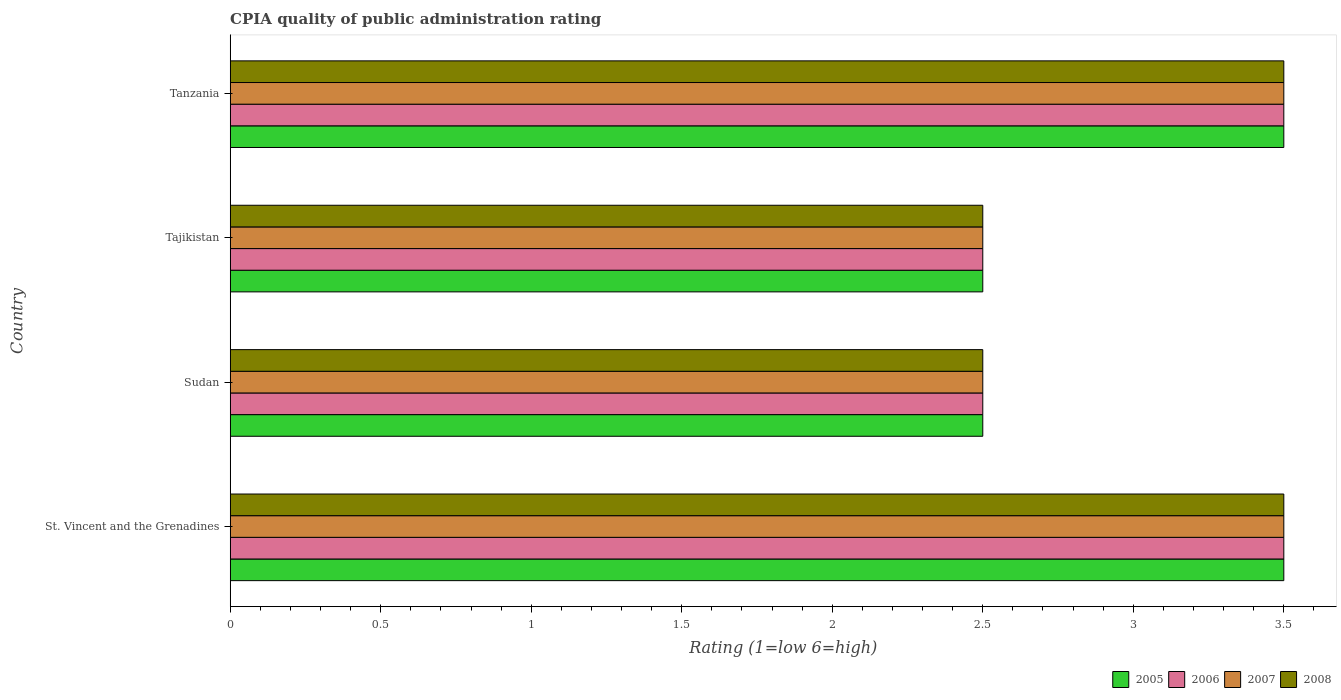How many different coloured bars are there?
Provide a short and direct response. 4. Are the number of bars on each tick of the Y-axis equal?
Give a very brief answer. Yes. What is the label of the 3rd group of bars from the top?
Offer a terse response. Sudan. In how many cases, is the number of bars for a given country not equal to the number of legend labels?
Keep it short and to the point. 0. What is the CPIA rating in 2008 in St. Vincent and the Grenadines?
Your answer should be very brief. 3.5. Across all countries, what is the minimum CPIA rating in 2007?
Provide a succinct answer. 2.5. In which country was the CPIA rating in 2008 maximum?
Ensure brevity in your answer.  St. Vincent and the Grenadines. In which country was the CPIA rating in 2007 minimum?
Keep it short and to the point. Sudan. What is the average CPIA rating in 2006 per country?
Your answer should be compact. 3. What is the difference between the CPIA rating in 2007 and CPIA rating in 2006 in St. Vincent and the Grenadines?
Your answer should be very brief. 0. Is the CPIA rating in 2005 in St. Vincent and the Grenadines less than that in Sudan?
Give a very brief answer. No. Is the difference between the CPIA rating in 2007 in St. Vincent and the Grenadines and Sudan greater than the difference between the CPIA rating in 2006 in St. Vincent and the Grenadines and Sudan?
Your answer should be compact. No. What is the difference between the highest and the second highest CPIA rating in 2005?
Your answer should be compact. 0. What is the difference between the highest and the lowest CPIA rating in 2007?
Give a very brief answer. 1. In how many countries, is the CPIA rating in 2006 greater than the average CPIA rating in 2006 taken over all countries?
Provide a short and direct response. 2. Is it the case that in every country, the sum of the CPIA rating in 2007 and CPIA rating in 2005 is greater than the sum of CPIA rating in 2008 and CPIA rating in 2006?
Provide a succinct answer. No. What does the 3rd bar from the top in St. Vincent and the Grenadines represents?
Provide a succinct answer. 2006. What does the 3rd bar from the bottom in St. Vincent and the Grenadines represents?
Offer a very short reply. 2007. Is it the case that in every country, the sum of the CPIA rating in 2007 and CPIA rating in 2008 is greater than the CPIA rating in 2006?
Make the answer very short. Yes. Are the values on the major ticks of X-axis written in scientific E-notation?
Your answer should be very brief. No. Where does the legend appear in the graph?
Your response must be concise. Bottom right. How many legend labels are there?
Keep it short and to the point. 4. How are the legend labels stacked?
Your response must be concise. Horizontal. What is the title of the graph?
Keep it short and to the point. CPIA quality of public administration rating. What is the label or title of the Y-axis?
Offer a terse response. Country. What is the Rating (1=low 6=high) of 2007 in St. Vincent and the Grenadines?
Offer a very short reply. 3.5. What is the Rating (1=low 6=high) in 2008 in St. Vincent and the Grenadines?
Make the answer very short. 3.5. What is the Rating (1=low 6=high) of 2006 in Sudan?
Offer a very short reply. 2.5. What is the Rating (1=low 6=high) in 2007 in Sudan?
Keep it short and to the point. 2.5. What is the Rating (1=low 6=high) in 2008 in Sudan?
Ensure brevity in your answer.  2.5. What is the Rating (1=low 6=high) of 2007 in Tajikistan?
Give a very brief answer. 2.5. What is the Rating (1=low 6=high) of 2006 in Tanzania?
Your response must be concise. 3.5. What is the Rating (1=low 6=high) of 2008 in Tanzania?
Give a very brief answer. 3.5. Across all countries, what is the maximum Rating (1=low 6=high) in 2005?
Offer a very short reply. 3.5. Across all countries, what is the maximum Rating (1=low 6=high) of 2006?
Ensure brevity in your answer.  3.5. Across all countries, what is the maximum Rating (1=low 6=high) in 2007?
Give a very brief answer. 3.5. What is the total Rating (1=low 6=high) in 2008 in the graph?
Offer a terse response. 12. What is the difference between the Rating (1=low 6=high) in 2005 in St. Vincent and the Grenadines and that in Sudan?
Provide a succinct answer. 1. What is the difference between the Rating (1=low 6=high) in 2007 in St. Vincent and the Grenadines and that in Sudan?
Provide a succinct answer. 1. What is the difference between the Rating (1=low 6=high) in 2005 in St. Vincent and the Grenadines and that in Tajikistan?
Provide a succinct answer. 1. What is the difference between the Rating (1=low 6=high) of 2007 in St. Vincent and the Grenadines and that in Tajikistan?
Ensure brevity in your answer.  1. What is the difference between the Rating (1=low 6=high) in 2008 in St. Vincent and the Grenadines and that in Tajikistan?
Your answer should be compact. 1. What is the difference between the Rating (1=low 6=high) of 2008 in Sudan and that in Tajikistan?
Give a very brief answer. 0. What is the difference between the Rating (1=low 6=high) of 2008 in Sudan and that in Tanzania?
Your response must be concise. -1. What is the difference between the Rating (1=low 6=high) of 2007 in Tajikistan and that in Tanzania?
Provide a short and direct response. -1. What is the difference between the Rating (1=low 6=high) in 2008 in Tajikistan and that in Tanzania?
Your answer should be very brief. -1. What is the difference between the Rating (1=low 6=high) in 2005 in St. Vincent and the Grenadines and the Rating (1=low 6=high) in 2006 in Sudan?
Provide a succinct answer. 1. What is the difference between the Rating (1=low 6=high) of 2005 in St. Vincent and the Grenadines and the Rating (1=low 6=high) of 2007 in Sudan?
Your answer should be very brief. 1. What is the difference between the Rating (1=low 6=high) of 2005 in St. Vincent and the Grenadines and the Rating (1=low 6=high) of 2007 in Tajikistan?
Ensure brevity in your answer.  1. What is the difference between the Rating (1=low 6=high) of 2005 in St. Vincent and the Grenadines and the Rating (1=low 6=high) of 2008 in Tajikistan?
Offer a very short reply. 1. What is the difference between the Rating (1=low 6=high) in 2006 in St. Vincent and the Grenadines and the Rating (1=low 6=high) in 2007 in Tajikistan?
Offer a terse response. 1. What is the difference between the Rating (1=low 6=high) of 2006 in St. Vincent and the Grenadines and the Rating (1=low 6=high) of 2008 in Tajikistan?
Give a very brief answer. 1. What is the difference between the Rating (1=low 6=high) of 2005 in St. Vincent and the Grenadines and the Rating (1=low 6=high) of 2006 in Tanzania?
Offer a very short reply. 0. What is the difference between the Rating (1=low 6=high) of 2005 in St. Vincent and the Grenadines and the Rating (1=low 6=high) of 2007 in Tanzania?
Keep it short and to the point. 0. What is the difference between the Rating (1=low 6=high) of 2005 in St. Vincent and the Grenadines and the Rating (1=low 6=high) of 2008 in Tanzania?
Offer a very short reply. 0. What is the difference between the Rating (1=low 6=high) in 2006 in St. Vincent and the Grenadines and the Rating (1=low 6=high) in 2007 in Tanzania?
Offer a terse response. 0. What is the difference between the Rating (1=low 6=high) in 2005 in Sudan and the Rating (1=low 6=high) in 2006 in Tajikistan?
Your answer should be compact. 0. What is the difference between the Rating (1=low 6=high) of 2005 in Sudan and the Rating (1=low 6=high) of 2008 in Tajikistan?
Your response must be concise. 0. What is the difference between the Rating (1=low 6=high) of 2006 in Sudan and the Rating (1=low 6=high) of 2008 in Tajikistan?
Your response must be concise. 0. What is the difference between the Rating (1=low 6=high) of 2007 in Sudan and the Rating (1=low 6=high) of 2008 in Tajikistan?
Ensure brevity in your answer.  0. What is the difference between the Rating (1=low 6=high) of 2005 in Sudan and the Rating (1=low 6=high) of 2006 in Tanzania?
Provide a short and direct response. -1. What is the difference between the Rating (1=low 6=high) of 2005 in Sudan and the Rating (1=low 6=high) of 2008 in Tanzania?
Ensure brevity in your answer.  -1. What is the difference between the Rating (1=low 6=high) of 2006 in Sudan and the Rating (1=low 6=high) of 2007 in Tanzania?
Ensure brevity in your answer.  -1. What is the difference between the Rating (1=low 6=high) in 2006 in Sudan and the Rating (1=low 6=high) in 2008 in Tanzania?
Give a very brief answer. -1. What is the difference between the Rating (1=low 6=high) in 2007 in Sudan and the Rating (1=low 6=high) in 2008 in Tanzania?
Offer a terse response. -1. What is the difference between the Rating (1=low 6=high) of 2005 in Tajikistan and the Rating (1=low 6=high) of 2006 in Tanzania?
Your answer should be very brief. -1. What is the difference between the Rating (1=low 6=high) of 2006 in Tajikistan and the Rating (1=low 6=high) of 2007 in Tanzania?
Make the answer very short. -1. What is the difference between the Rating (1=low 6=high) of 2007 in Tajikistan and the Rating (1=low 6=high) of 2008 in Tanzania?
Make the answer very short. -1. What is the average Rating (1=low 6=high) in 2005 per country?
Provide a succinct answer. 3. What is the difference between the Rating (1=low 6=high) of 2005 and Rating (1=low 6=high) of 2007 in St. Vincent and the Grenadines?
Your answer should be compact. 0. What is the difference between the Rating (1=low 6=high) of 2005 and Rating (1=low 6=high) of 2008 in St. Vincent and the Grenadines?
Give a very brief answer. 0. What is the difference between the Rating (1=low 6=high) in 2006 and Rating (1=low 6=high) in 2008 in St. Vincent and the Grenadines?
Your answer should be very brief. 0. What is the difference between the Rating (1=low 6=high) in 2007 and Rating (1=low 6=high) in 2008 in St. Vincent and the Grenadines?
Your answer should be very brief. 0. What is the difference between the Rating (1=low 6=high) in 2006 and Rating (1=low 6=high) in 2008 in Sudan?
Your answer should be compact. 0. What is the difference between the Rating (1=low 6=high) of 2005 and Rating (1=low 6=high) of 2007 in Tajikistan?
Offer a very short reply. 0. What is the difference between the Rating (1=low 6=high) of 2006 and Rating (1=low 6=high) of 2008 in Tajikistan?
Offer a terse response. 0. What is the difference between the Rating (1=low 6=high) of 2007 and Rating (1=low 6=high) of 2008 in Tajikistan?
Ensure brevity in your answer.  0. What is the difference between the Rating (1=low 6=high) in 2006 and Rating (1=low 6=high) in 2007 in Tanzania?
Your response must be concise. 0. What is the difference between the Rating (1=low 6=high) of 2006 and Rating (1=low 6=high) of 2008 in Tanzania?
Keep it short and to the point. 0. What is the difference between the Rating (1=low 6=high) in 2007 and Rating (1=low 6=high) in 2008 in Tanzania?
Provide a short and direct response. 0. What is the ratio of the Rating (1=low 6=high) in 2006 in St. Vincent and the Grenadines to that in Sudan?
Offer a terse response. 1.4. What is the ratio of the Rating (1=low 6=high) in 2005 in St. Vincent and the Grenadines to that in Tajikistan?
Your answer should be compact. 1.4. What is the ratio of the Rating (1=low 6=high) in 2006 in St. Vincent and the Grenadines to that in Tajikistan?
Offer a terse response. 1.4. What is the ratio of the Rating (1=low 6=high) of 2008 in St. Vincent and the Grenadines to that in Tajikistan?
Make the answer very short. 1.4. What is the ratio of the Rating (1=low 6=high) in 2007 in St. Vincent and the Grenadines to that in Tanzania?
Offer a terse response. 1. What is the ratio of the Rating (1=low 6=high) of 2006 in Sudan to that in Tajikistan?
Ensure brevity in your answer.  1. What is the ratio of the Rating (1=low 6=high) in 2007 in Sudan to that in Tajikistan?
Provide a succinct answer. 1. What is the ratio of the Rating (1=low 6=high) of 2008 in Sudan to that in Tajikistan?
Offer a very short reply. 1. What is the ratio of the Rating (1=low 6=high) of 2008 in Sudan to that in Tanzania?
Provide a succinct answer. 0.71. What is the ratio of the Rating (1=low 6=high) in 2006 in Tajikistan to that in Tanzania?
Your answer should be very brief. 0.71. What is the difference between the highest and the second highest Rating (1=low 6=high) in 2006?
Keep it short and to the point. 0. What is the difference between the highest and the lowest Rating (1=low 6=high) of 2006?
Ensure brevity in your answer.  1. What is the difference between the highest and the lowest Rating (1=low 6=high) in 2008?
Your answer should be very brief. 1. 